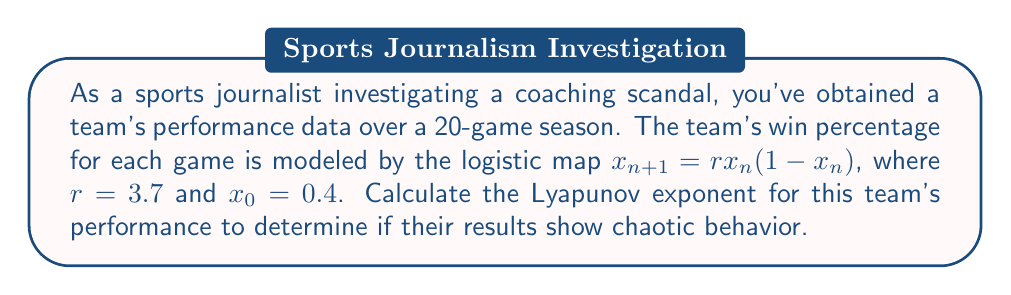Can you answer this question? To calculate the Lyapunov exponent for the team's performance, we'll follow these steps:

1) The Lyapunov exponent for the logistic map is given by:

   $$\lambda = \lim_{n \to \infty} \frac{1}{n} \sum_{i=0}^{n-1} \ln|f'(x_i)|$$

   where $f'(x) = r(1-2x)$ for the logistic map.

2) We need to iterate the map for 20 games:
   $x_0 = 0.4$
   $x_1 = 3.7 \cdot 0.4 \cdot (1-0.4) = 0.888$
   $x_2 = 3.7 \cdot 0.888 \cdot (1-0.888) = 0.3681$
   ...and so on until $x_{19}$

3) For each $x_i$, calculate $|f'(x_i)| = |3.7(1-2x_i)|$:
   $|f'(x_0)| = |3.7(1-2\cdot0.4)| = 0.74$
   $|f'(x_1)| = |3.7(1-2\cdot0.888)| = 2.8856$
   $|f'(x_2)| = |3.7(1-2\cdot0.3681)| = 0.9761$
   ...and so on

4) Take the natural log of each $|f'(x_i)|$:
   $\ln|f'(x_0)| = \ln(0.74) = -0.3011$
   $\ln|f'(x_1)| = \ln(2.8856) = 1.0598$
   $\ln|f'(x_2)| = \ln(0.9761) = -0.0242$
   ...and so on

5) Sum all these logarithms and divide by 20:

   $$\lambda \approx \frac{1}{20} \sum_{i=0}^{19} \ln|f'(x_i)| \approx 0.5365$$

6) Since $\lambda > 0$, the team's performance exhibits chaotic behavior.
Answer: $\lambda \approx 0.5365$ 